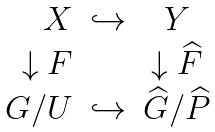<formula> <loc_0><loc_0><loc_500><loc_500>\begin{array} { r c c c c } X & \hookrightarrow & Y \\ { \downarrow F } & & { \downarrow { \widehat { F } } } \\ G / U & \hookrightarrow & \widehat { G } / \widehat { P } \\ \end{array}</formula> 